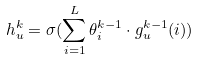<formula> <loc_0><loc_0><loc_500><loc_500>h _ { u } ^ { k } = \sigma ( \sum _ { i = 1 } ^ { L } \theta _ { i } ^ { k - 1 } \cdot g _ { u } ^ { k - 1 } ( i ) )</formula> 